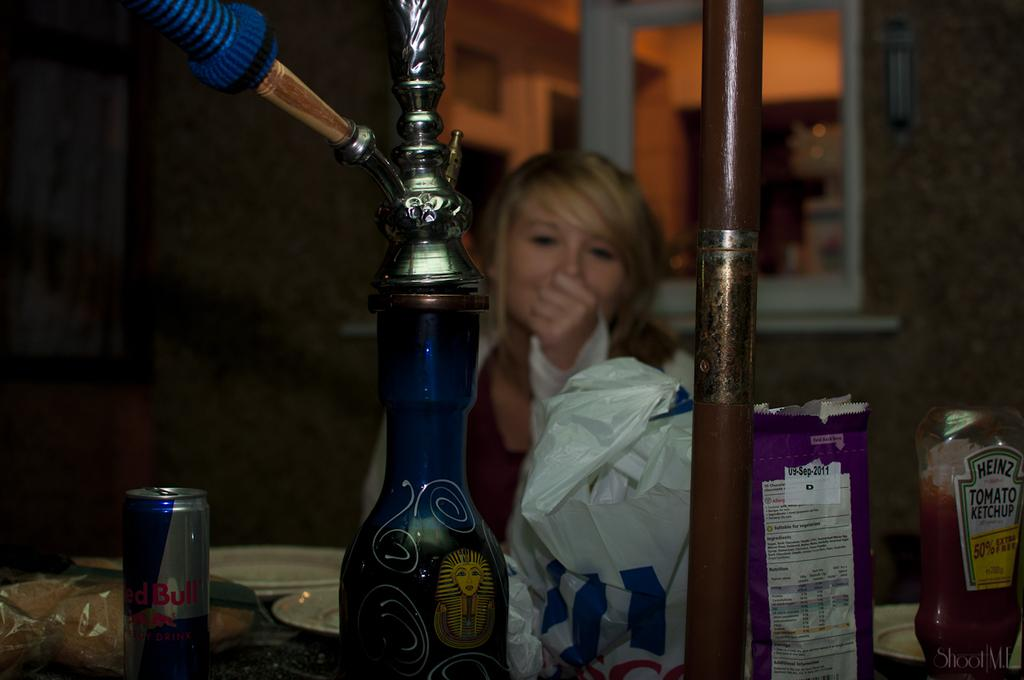<image>
Share a concise interpretation of the image provided. A bottle of Heinz tomato ketchup on the table where the woman is sitting. 